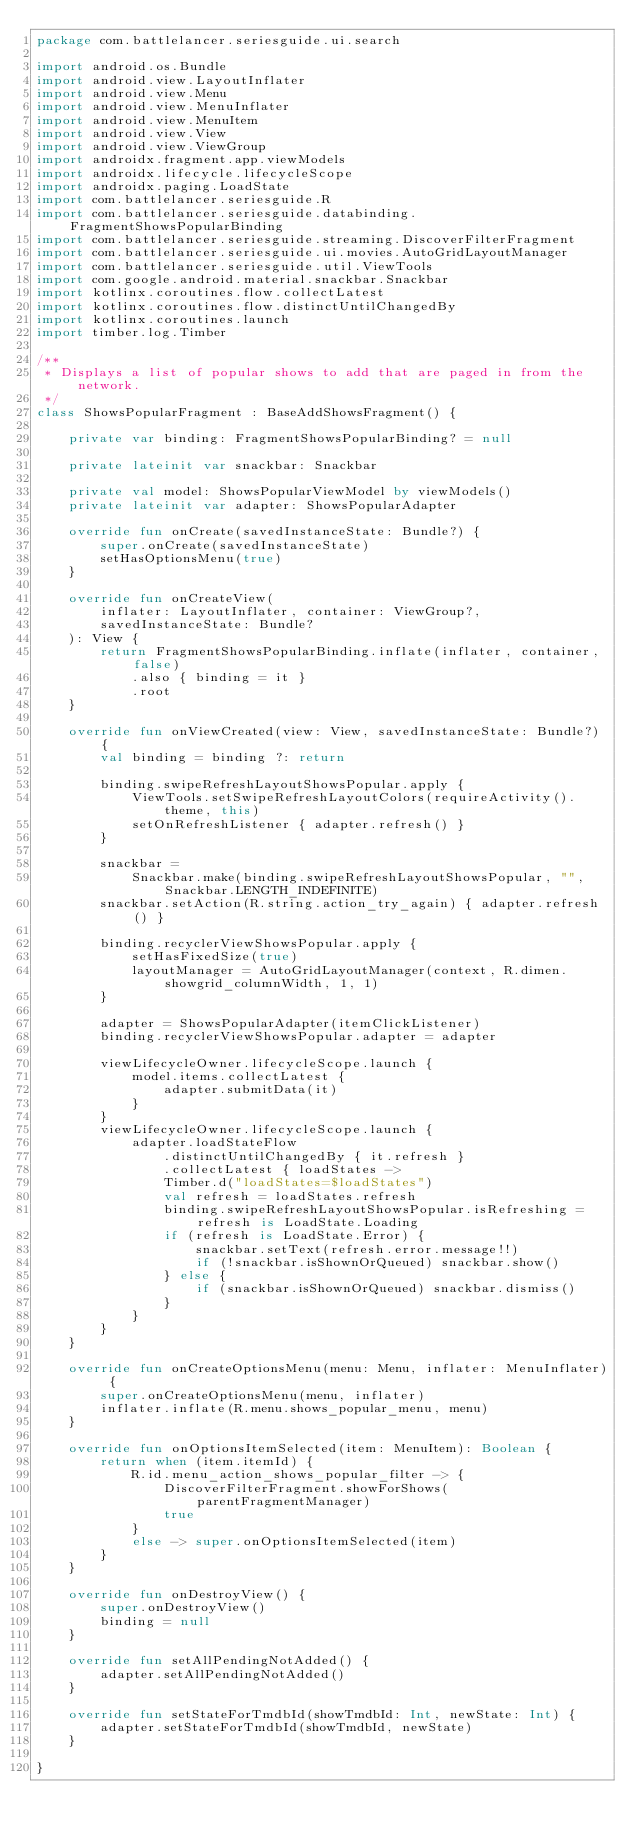Convert code to text. <code><loc_0><loc_0><loc_500><loc_500><_Kotlin_>package com.battlelancer.seriesguide.ui.search

import android.os.Bundle
import android.view.LayoutInflater
import android.view.Menu
import android.view.MenuInflater
import android.view.MenuItem
import android.view.View
import android.view.ViewGroup
import androidx.fragment.app.viewModels
import androidx.lifecycle.lifecycleScope
import androidx.paging.LoadState
import com.battlelancer.seriesguide.R
import com.battlelancer.seriesguide.databinding.FragmentShowsPopularBinding
import com.battlelancer.seriesguide.streaming.DiscoverFilterFragment
import com.battlelancer.seriesguide.ui.movies.AutoGridLayoutManager
import com.battlelancer.seriesguide.util.ViewTools
import com.google.android.material.snackbar.Snackbar
import kotlinx.coroutines.flow.collectLatest
import kotlinx.coroutines.flow.distinctUntilChangedBy
import kotlinx.coroutines.launch
import timber.log.Timber

/**
 * Displays a list of popular shows to add that are paged in from the network.
 */
class ShowsPopularFragment : BaseAddShowsFragment() {

    private var binding: FragmentShowsPopularBinding? = null

    private lateinit var snackbar: Snackbar

    private val model: ShowsPopularViewModel by viewModels()
    private lateinit var adapter: ShowsPopularAdapter

    override fun onCreate(savedInstanceState: Bundle?) {
        super.onCreate(savedInstanceState)
        setHasOptionsMenu(true)
    }

    override fun onCreateView(
        inflater: LayoutInflater, container: ViewGroup?,
        savedInstanceState: Bundle?
    ): View {
        return FragmentShowsPopularBinding.inflate(inflater, container, false)
            .also { binding = it }
            .root
    }

    override fun onViewCreated(view: View, savedInstanceState: Bundle?) {
        val binding = binding ?: return

        binding.swipeRefreshLayoutShowsPopular.apply {
            ViewTools.setSwipeRefreshLayoutColors(requireActivity().theme, this)
            setOnRefreshListener { adapter.refresh() }
        }

        snackbar =
            Snackbar.make(binding.swipeRefreshLayoutShowsPopular, "", Snackbar.LENGTH_INDEFINITE)
        snackbar.setAction(R.string.action_try_again) { adapter.refresh() }

        binding.recyclerViewShowsPopular.apply {
            setHasFixedSize(true)
            layoutManager = AutoGridLayoutManager(context, R.dimen.showgrid_columnWidth, 1, 1)
        }

        adapter = ShowsPopularAdapter(itemClickListener)
        binding.recyclerViewShowsPopular.adapter = adapter

        viewLifecycleOwner.lifecycleScope.launch {
            model.items.collectLatest {
                adapter.submitData(it)
            }
        }
        viewLifecycleOwner.lifecycleScope.launch {
            adapter.loadStateFlow
                .distinctUntilChangedBy { it.refresh }
                .collectLatest { loadStates ->
                Timber.d("loadStates=$loadStates")
                val refresh = loadStates.refresh
                binding.swipeRefreshLayoutShowsPopular.isRefreshing = refresh is LoadState.Loading
                if (refresh is LoadState.Error) {
                    snackbar.setText(refresh.error.message!!)
                    if (!snackbar.isShownOrQueued) snackbar.show()
                } else {
                    if (snackbar.isShownOrQueued) snackbar.dismiss()
                }
            }
        }
    }

    override fun onCreateOptionsMenu(menu: Menu, inflater: MenuInflater) {
        super.onCreateOptionsMenu(menu, inflater)
        inflater.inflate(R.menu.shows_popular_menu, menu)
    }

    override fun onOptionsItemSelected(item: MenuItem): Boolean {
        return when (item.itemId) {
            R.id.menu_action_shows_popular_filter -> {
                DiscoverFilterFragment.showForShows(parentFragmentManager)
                true
            }
            else -> super.onOptionsItemSelected(item)
        }
    }

    override fun onDestroyView() {
        super.onDestroyView()
        binding = null
    }

    override fun setAllPendingNotAdded() {
        adapter.setAllPendingNotAdded()
    }

    override fun setStateForTmdbId(showTmdbId: Int, newState: Int) {
        adapter.setStateForTmdbId(showTmdbId, newState)
    }

}</code> 